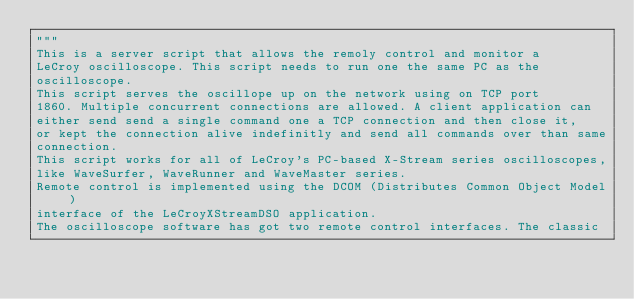Convert code to text. <code><loc_0><loc_0><loc_500><loc_500><_Python_>"""
This is a server script that allows the remoly control and monitor a
LeCroy oscilloscope. This script needs to run one the same PC as the
oscilloscope.
This script serves the oscillope up on the network using on TCP port
1860. Multiple concurrent connections are allowed. A client application can
either send send a single command one a TCP connection and then close it,
or kept the connection alive indefinitly and send all commands over than same
connection.
This script works for all of LeCroy's PC-based X-Stream series oscilloscopes,
like WaveSurfer, WaveRunner and WaveMaster series.
Remote control is implemented using the DCOM (Distributes Common Object Model)
interface of the LeCroyXStreamDSO application.
The oscilloscope software has got two remote control interfaces. The classic</code> 